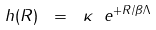<formula> <loc_0><loc_0><loc_500><loc_500>h ( R ) \ = \ \kappa \ e ^ { + R / \beta \Lambda }</formula> 